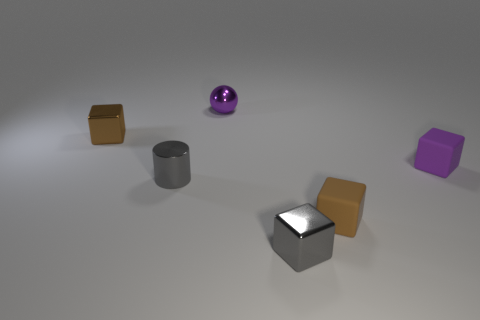Subtract all yellow blocks. Subtract all cyan spheres. How many blocks are left? 4 Add 1 brown rubber cylinders. How many objects exist? 7 Subtract all cylinders. How many objects are left? 5 Subtract 0 blue blocks. How many objects are left? 6 Subtract all rubber blocks. Subtract all gray metal cylinders. How many objects are left? 3 Add 4 tiny cylinders. How many tiny cylinders are left? 5 Add 3 small matte things. How many small matte things exist? 5 